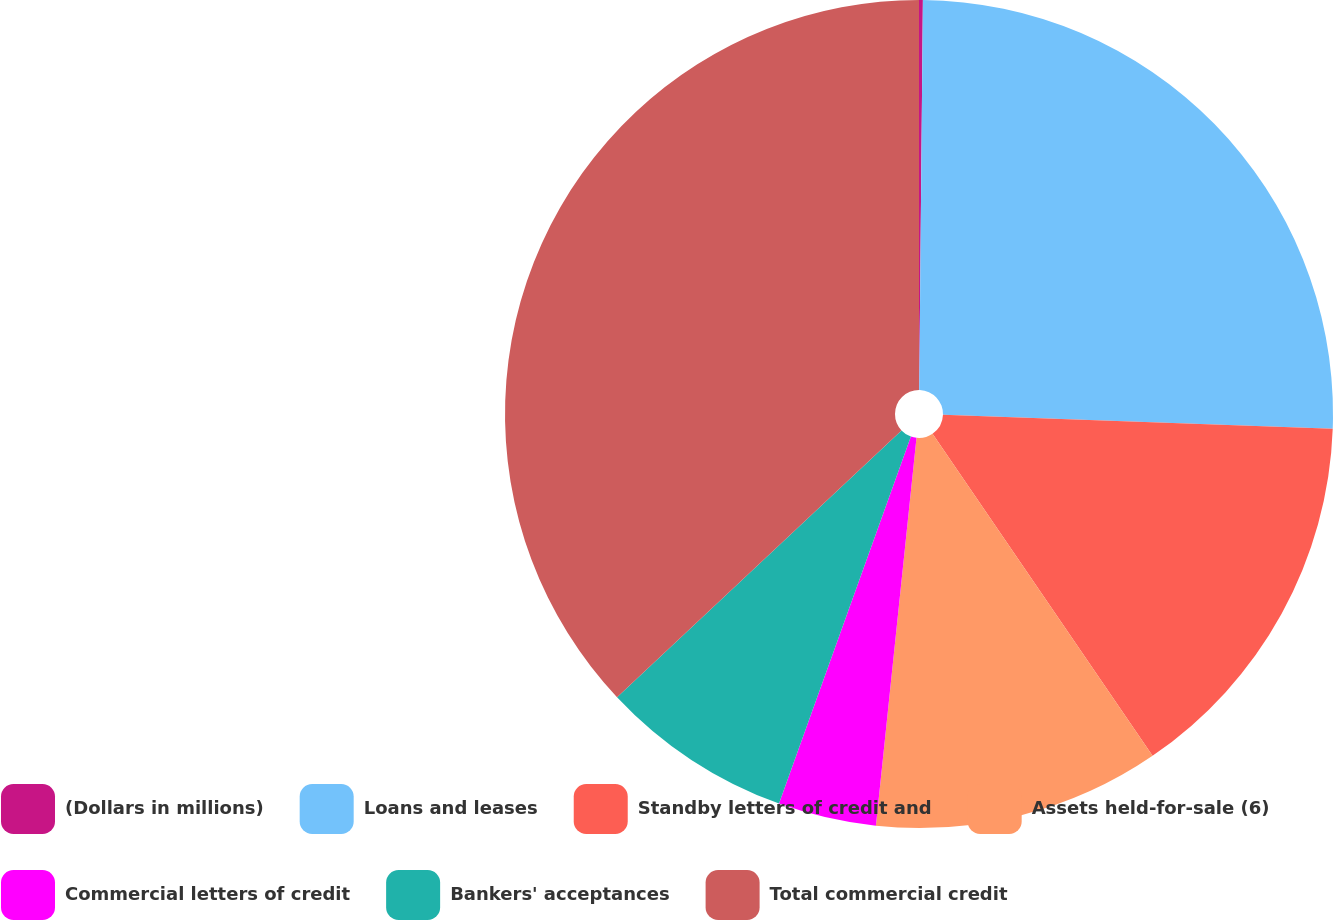Convert chart to OTSL. <chart><loc_0><loc_0><loc_500><loc_500><pie_chart><fcel>(Dollars in millions)<fcel>Loans and leases<fcel>Standby letters of credit and<fcel>Assets held-for-sale (6)<fcel>Commercial letters of credit<fcel>Bankers' acceptances<fcel>Total commercial credit<nl><fcel>0.15%<fcel>25.42%<fcel>14.89%<fcel>11.2%<fcel>3.83%<fcel>7.52%<fcel>36.99%<nl></chart> 